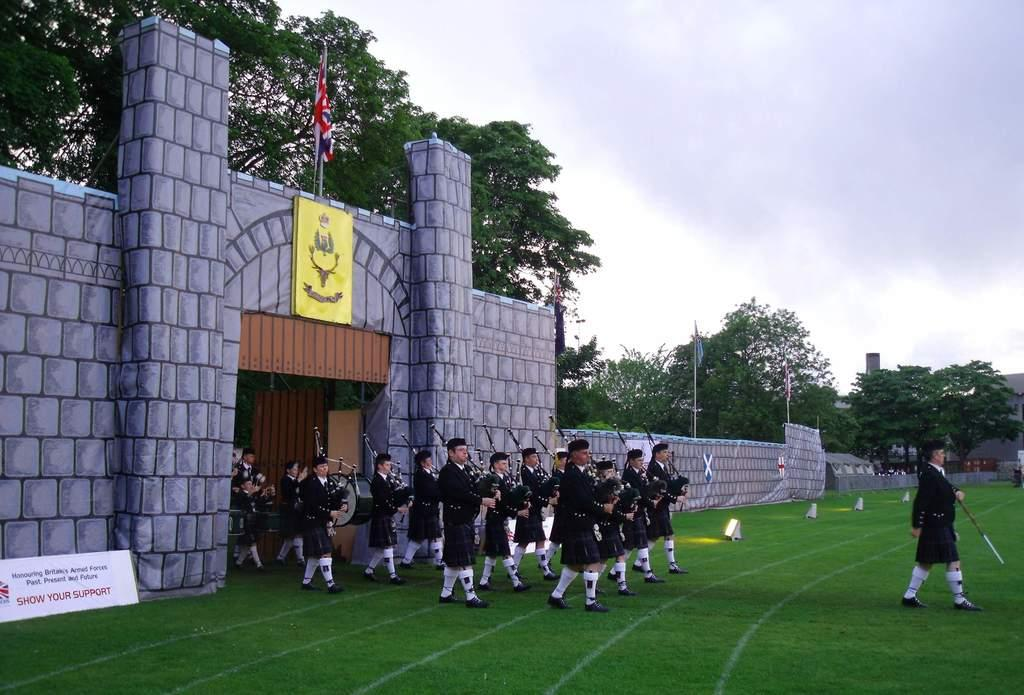<image>
Describe the image concisely. A group of Scottish band members are marching onto a field by a sign that says Show Your Support. 